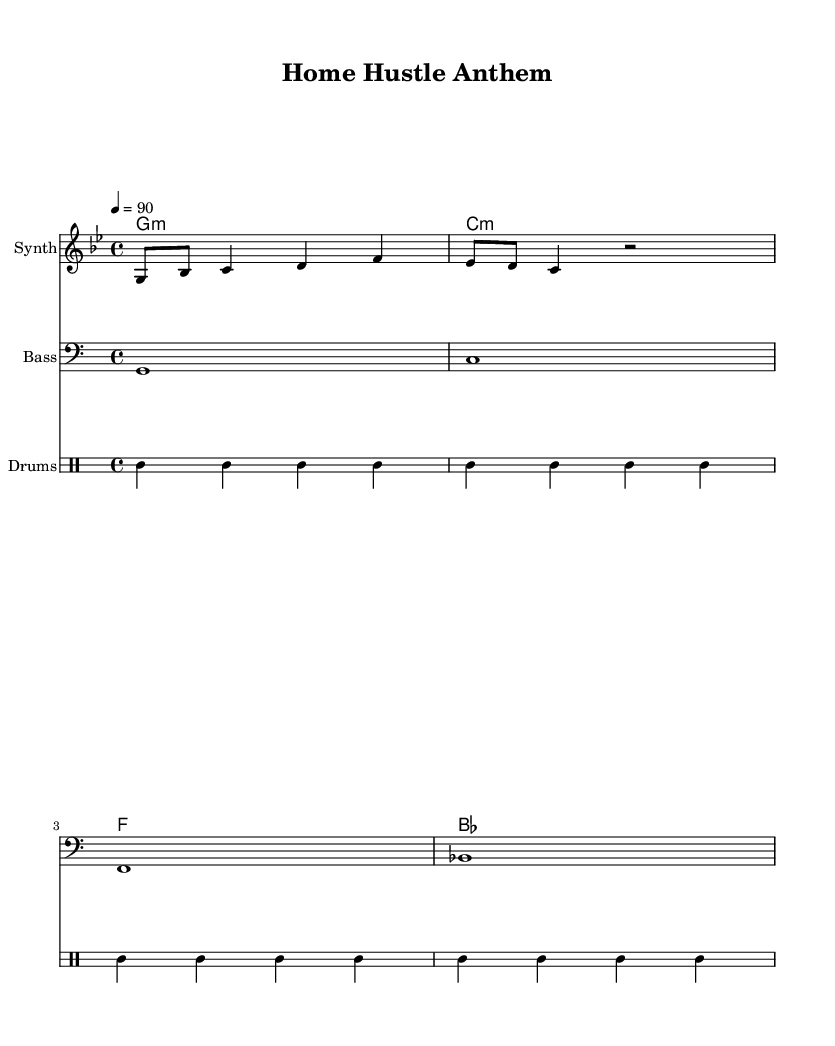What is the key signature of this music? The key signature is indicated at the beginning of the score after the clef symbol. Here, it shows one flat, which corresponds to the key of G minor.
Answer: G minor What is the time signature of this music? The time signature is usually found right after the key signature. Here, it shows 4/4, which means there are four beats per measure and the quarter note gets the beat.
Answer: 4/4 What is the tempo marking of this music? The tempo marking is indicated above the staff. It shows a number with the word "tempo" next to it, which indicates the beats per minute (bpm). Here, it indicates a tempo of 90 beats per minute.
Answer: 90 How many measures are in the melody? To determine the number of measures, you can count the number of bar lines in the melody part. The melody has four measures as indicated by the separation of notes and bar lines.
Answer: 4 What type of lyrics are present in this rap? The lyrics are indicated in the lyric mode at the bottom of the score. They appear to focus on themes related to making progress and entrepreneurship, typical in motivational rap.
Answer: Empowering What instruments are used in this composition? The instruments are listed at the beginning of each staff in the score. There are three instruments: Synth for the melody, Bass for the bass part, and Drums for the percussion section.
Answer: Synth, Bass, Drums How is the drum pattern structured? The drum pattern can be analyzed in the drummode section. It shows a repeating pattern involving kick drums and snare, with closed hi-hat hits in between. Specifically, it repeats twice with kick followed by snare.
Answer: Repeating kick and snare pattern 